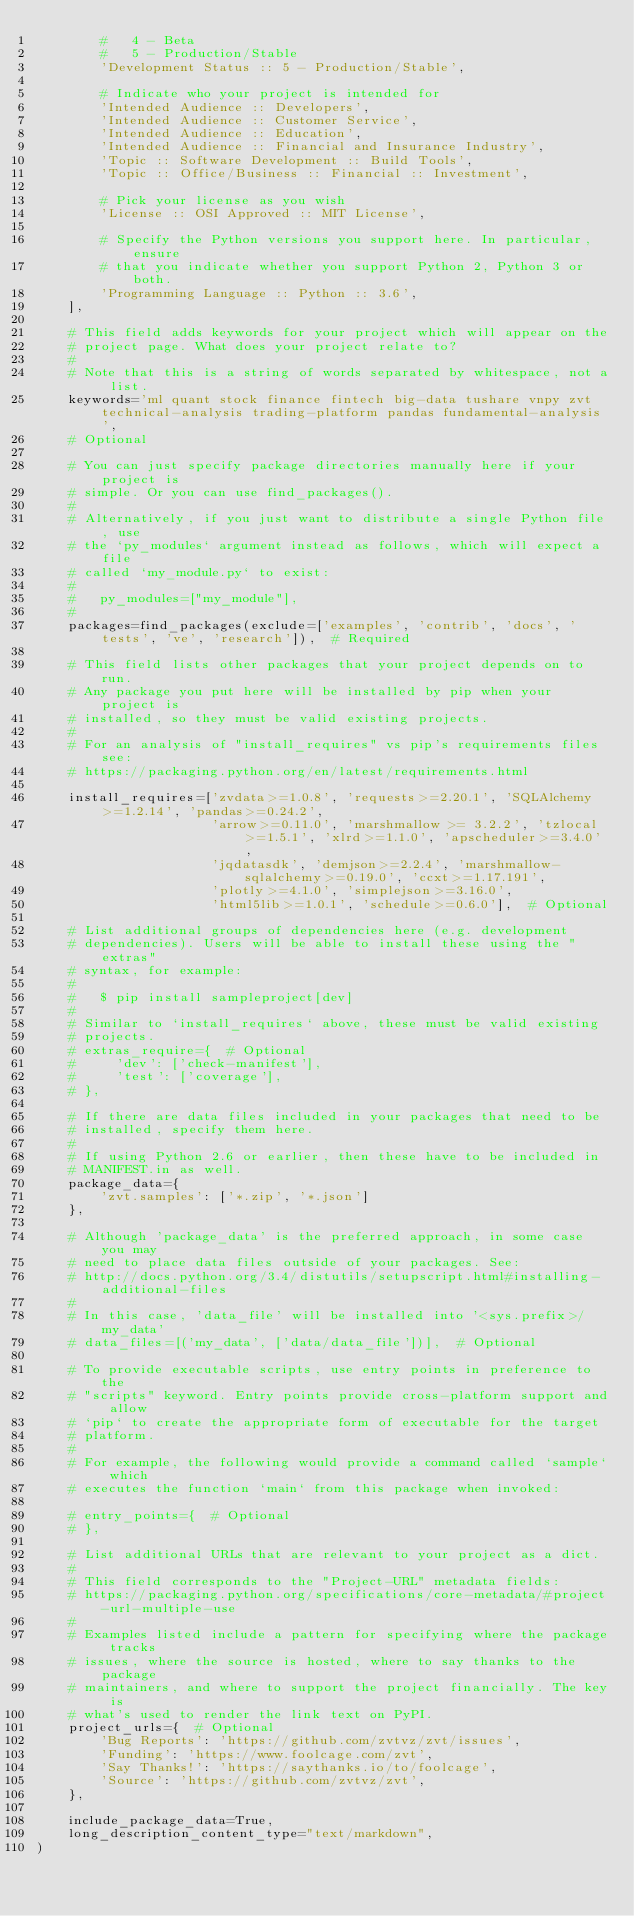Convert code to text. <code><loc_0><loc_0><loc_500><loc_500><_Python_>        #   4 - Beta
        #   5 - Production/Stable
        'Development Status :: 5 - Production/Stable',

        # Indicate who your project is intended for
        'Intended Audience :: Developers',
        'Intended Audience :: Customer Service',
        'Intended Audience :: Education',
        'Intended Audience :: Financial and Insurance Industry',
        'Topic :: Software Development :: Build Tools',
        'Topic :: Office/Business :: Financial :: Investment',

        # Pick your license as you wish
        'License :: OSI Approved :: MIT License',

        # Specify the Python versions you support here. In particular, ensure
        # that you indicate whether you support Python 2, Python 3 or both.
        'Programming Language :: Python :: 3.6',
    ],

    # This field adds keywords for your project which will appear on the
    # project page. What does your project relate to?
    #
    # Note that this is a string of words separated by whitespace, not a list.
    keywords='ml quant stock finance fintech big-data tushare vnpy zvt technical-analysis trading-platform pandas fundamental-analysis',
    # Optional

    # You can just specify package directories manually here if your project is
    # simple. Or you can use find_packages().
    #
    # Alternatively, if you just want to distribute a single Python file, use
    # the `py_modules` argument instead as follows, which will expect a file
    # called `my_module.py` to exist:
    #
    #   py_modules=["my_module"],
    #
    packages=find_packages(exclude=['examples', 'contrib', 'docs', 'tests', 've', 'research']),  # Required

    # This field lists other packages that your project depends on to run.
    # Any package you put here will be installed by pip when your project is
    # installed, so they must be valid existing projects.
    #
    # For an analysis of "install_requires" vs pip's requirements files see:
    # https://packaging.python.org/en/latest/requirements.html

    install_requires=['zvdata>=1.0.8', 'requests>=2.20.1', 'SQLAlchemy>=1.2.14', 'pandas>=0.24.2',
                      'arrow>=0.11.0', 'marshmallow >= 3.2.2', 'tzlocal>=1.5.1', 'xlrd>=1.1.0', 'apscheduler>=3.4.0',
                      'jqdatasdk', 'demjson>=2.2.4', 'marshmallow-sqlalchemy>=0.19.0', 'ccxt>=1.17.191',
                      'plotly>=4.1.0', 'simplejson>=3.16.0',
                      'html5lib>=1.0.1', 'schedule>=0.6.0'],  # Optional

    # List additional groups of dependencies here (e.g. development
    # dependencies). Users will be able to install these using the "extras"
    # syntax, for example:
    #
    #   $ pip install sampleproject[dev]
    #
    # Similar to `install_requires` above, these must be valid existing
    # projects.
    # extras_require={  # Optional
    #     'dev': ['check-manifest'],
    #     'test': ['coverage'],
    # },

    # If there are data files included in your packages that need to be
    # installed, specify them here.
    #
    # If using Python 2.6 or earlier, then these have to be included in
    # MANIFEST.in as well.
    package_data={
        'zvt.samples': ['*.zip', '*.json']
    },

    # Although 'package_data' is the preferred approach, in some case you may
    # need to place data files outside of your packages. See:
    # http://docs.python.org/3.4/distutils/setupscript.html#installing-additional-files
    #
    # In this case, 'data_file' will be installed into '<sys.prefix>/my_data'
    # data_files=[('my_data', ['data/data_file'])],  # Optional

    # To provide executable scripts, use entry points in preference to the
    # "scripts" keyword. Entry points provide cross-platform support and allow
    # `pip` to create the appropriate form of executable for the target
    # platform.
    #
    # For example, the following would provide a command called `sample` which
    # executes the function `main` from this package when invoked:

    # entry_points={  # Optional
    # },

    # List additional URLs that are relevant to your project as a dict.
    #
    # This field corresponds to the "Project-URL" metadata fields:
    # https://packaging.python.org/specifications/core-metadata/#project-url-multiple-use
    #
    # Examples listed include a pattern for specifying where the package tracks
    # issues, where the source is hosted, where to say thanks to the package
    # maintainers, and where to support the project financially. The key is
    # what's used to render the link text on PyPI.
    project_urls={  # Optional
        'Bug Reports': 'https://github.com/zvtvz/zvt/issues',
        'Funding': 'https://www.foolcage.com/zvt',
        'Say Thanks!': 'https://saythanks.io/to/foolcage',
        'Source': 'https://github.com/zvtvz/zvt',
    },

    include_package_data=True,
    long_description_content_type="text/markdown",
)
</code> 